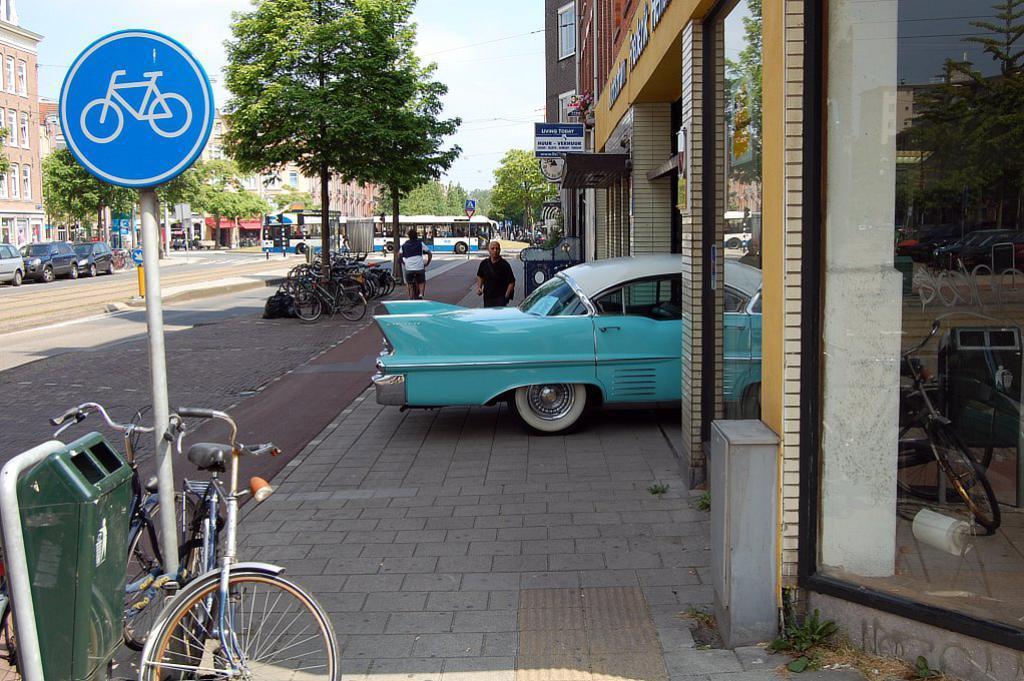How would you summarize this image in a sentence or two? In this image we can see many buildings. There are many vehicles in the image. There are few people in the image. We can see the sky in the image. There is a board in the image. We can see the reflections of trees, buildings and bicycles on the glass of the building at the right side of the image. There are many trees in the image. 